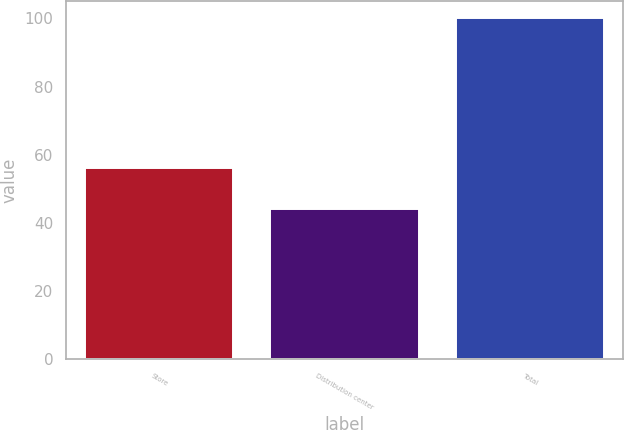Convert chart to OTSL. <chart><loc_0><loc_0><loc_500><loc_500><bar_chart><fcel>Store<fcel>Distribution center<fcel>Total<nl><fcel>56<fcel>44<fcel>100<nl></chart> 